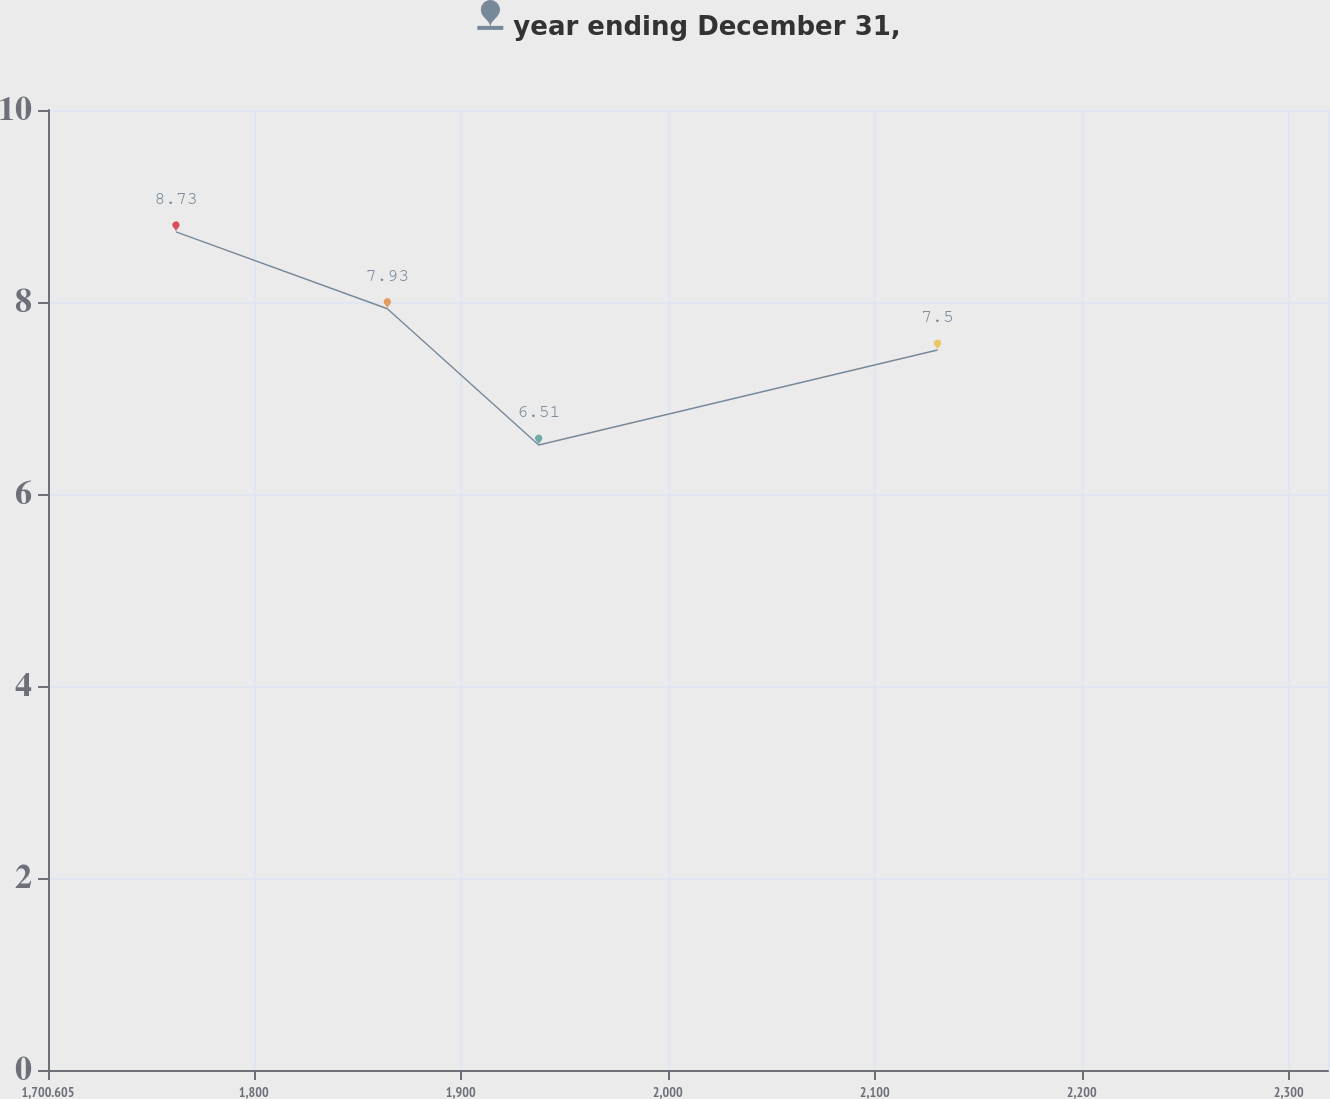Convert chart to OTSL. <chart><loc_0><loc_0><loc_500><loc_500><line_chart><ecel><fcel>year ending December 31,<nl><fcel>1762.44<fcel>8.73<nl><fcel>1864.55<fcel>7.93<nl><fcel>1937.67<fcel>6.51<nl><fcel>2130.32<fcel>7.5<nl><fcel>2380.79<fcel>6.26<nl></chart> 